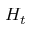<formula> <loc_0><loc_0><loc_500><loc_500>H _ { t }</formula> 